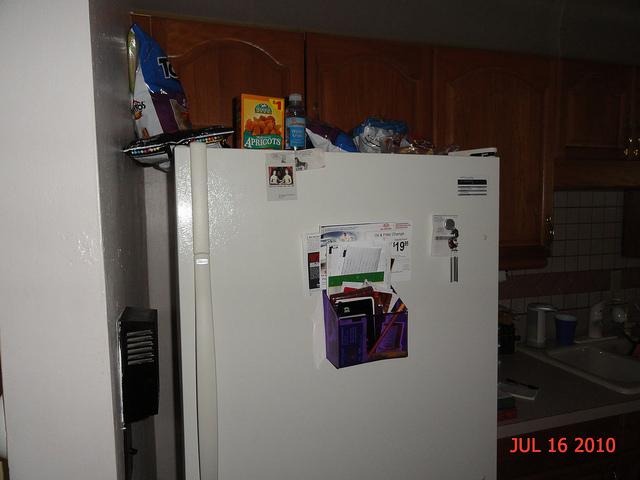Was the fridge built for a left or right handed user?
Concise answer only. Right. What type of chips are shown?
Answer briefly. Tostitos. When was the picture taken?
Be succinct. July 16 2010. What is the box on the refrigerator for?
Be succinct. Mail. Is there moss on the wall?
Be succinct. No. What is on the front of the refrigerator?
Short answer required. Organizer. What is written on the front of the fridge?
Quick response, please. 19.99. What does the text on the bag say?
Give a very brief answer. Tostitos. How would you contact someone if you needed help?
Answer briefly. Phone. 